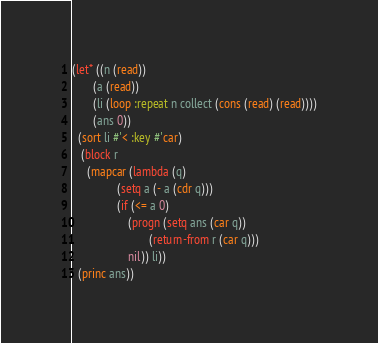Convert code to text. <code><loc_0><loc_0><loc_500><loc_500><_Lisp_>(let* ((n (read))
       (a (read))
       (li (loop :repeat n collect (cons (read) (read))))
       (ans 0))
  (sort li #'< :key #'car)
   (block r
     (mapcar (lambda (q)
               (setq a (- a (cdr q)))
               (if (<= a 0)
                   (progn (setq ans (car q))
                          (return-from r (car q)))
                   nil)) li))
  (princ ans))
</code> 